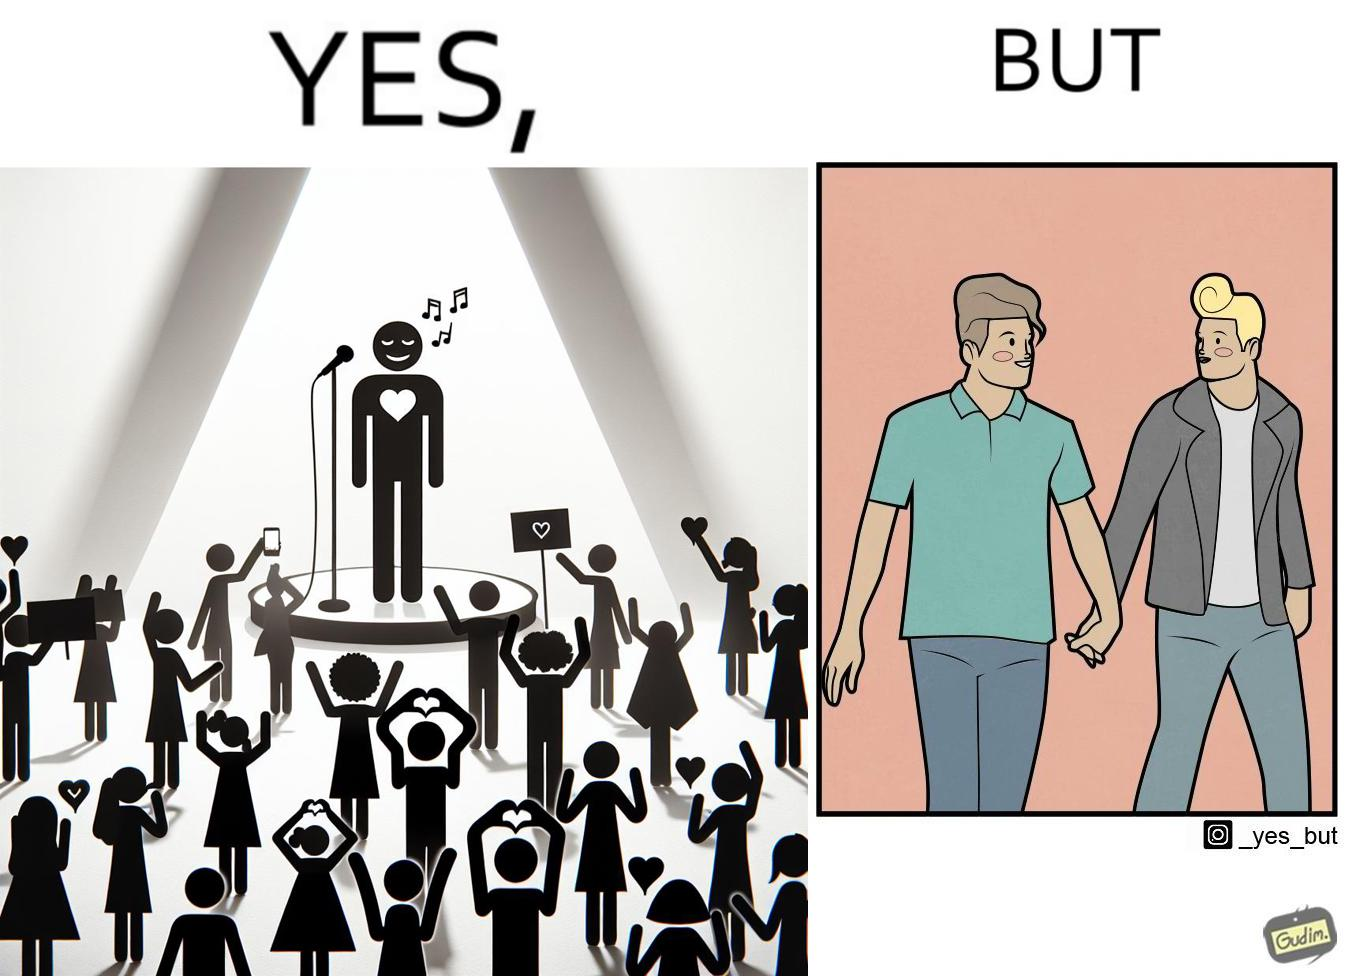Is this image satirical or non-satirical? Yes, this image is satirical. 